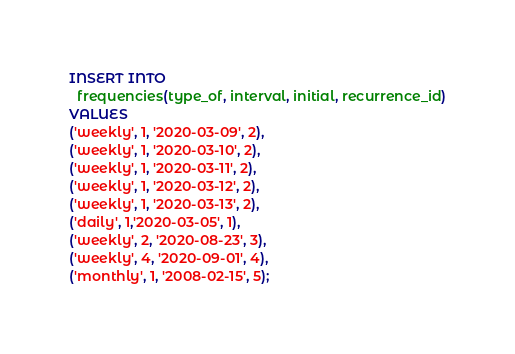Convert code to text. <code><loc_0><loc_0><loc_500><loc_500><_SQL_>INSERT INTO
  frequencies(type_of, interval, initial, recurrence_id)
VALUES
('weekly', 1, '2020-03-09', 2),
('weekly', 1, '2020-03-10', 2),
('weekly', 1, '2020-03-11', 2),
('weekly', 1, '2020-03-12', 2),
('weekly', 1, '2020-03-13', 2),
('daily', 1,'2020-03-05', 1),
('weekly', 2, '2020-08-23', 3),
('weekly', 4, '2020-09-01', 4),
('monthly', 1, '2008-02-15', 5);</code> 